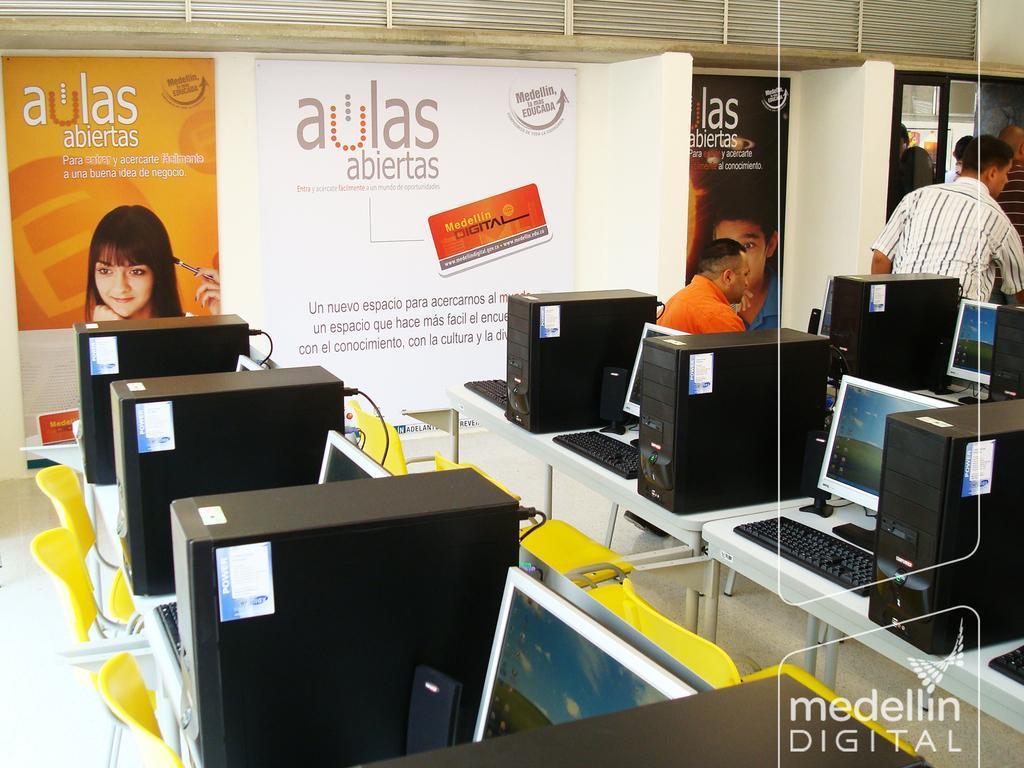Describe this image in one or two sentences. In this image it looks like an office. We can see that there are so many computers in the line. There are chairs in front of them. On the right side top there is a person. Behind him there is another person who is working. In the background there is a wall on which there are posters. At the top there are curtains. 